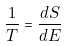<formula> <loc_0><loc_0><loc_500><loc_500>\frac { 1 } { T } = \frac { d S } { d E }</formula> 